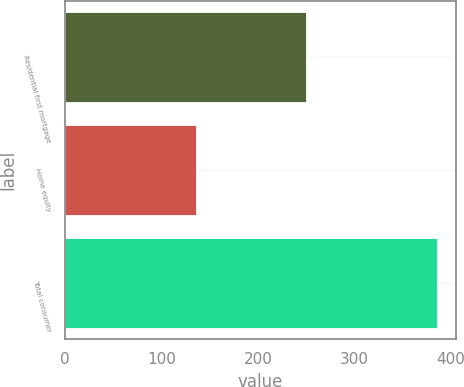Convert chart. <chart><loc_0><loc_0><loc_500><loc_500><bar_chart><fcel>Residential first mortgage<fcel>Home equity<fcel>Total consumer<nl><fcel>250<fcel>136<fcel>386<nl></chart> 